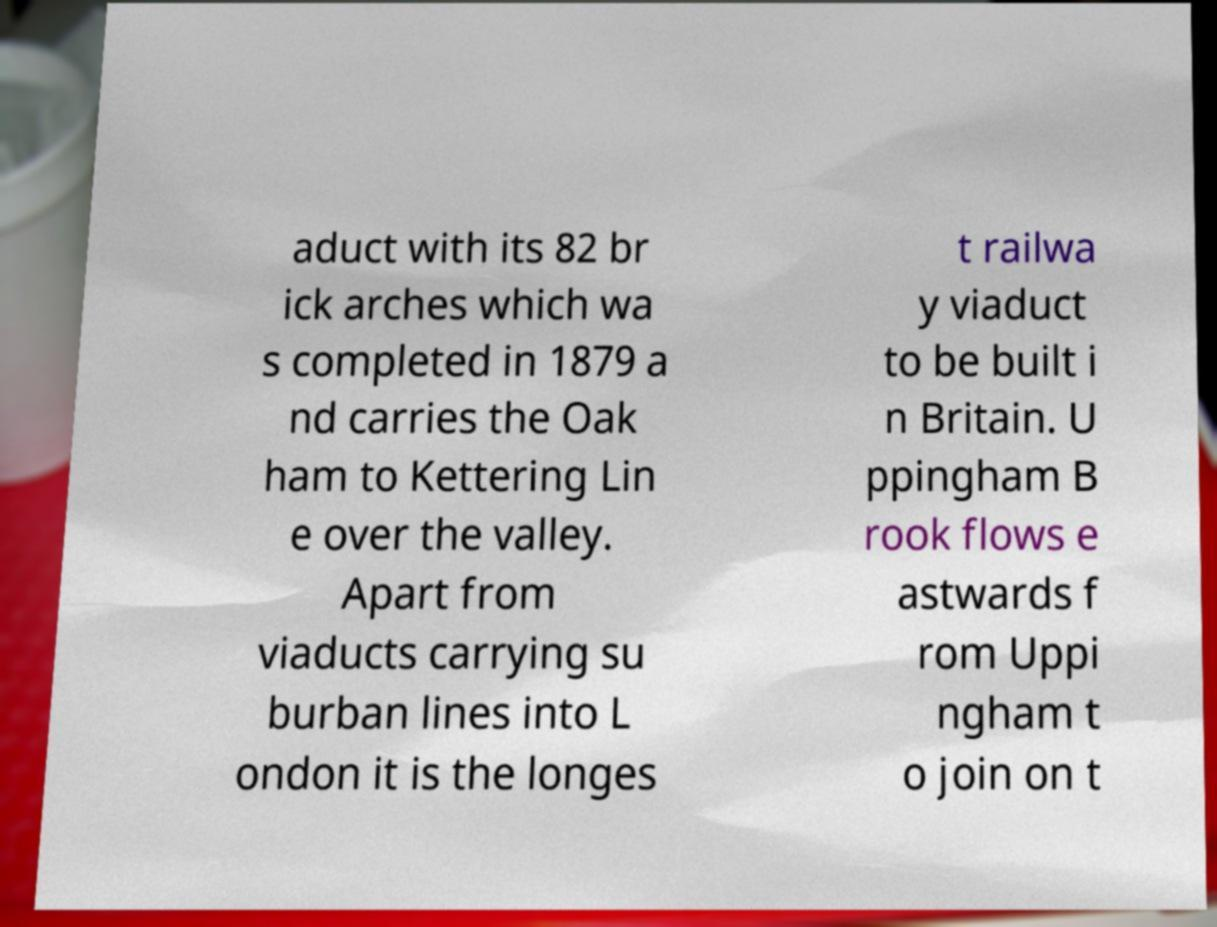Can you read and provide the text displayed in the image?This photo seems to have some interesting text. Can you extract and type it out for me? aduct with its 82 br ick arches which wa s completed in 1879 a nd carries the Oak ham to Kettering Lin e over the valley. Apart from viaducts carrying su burban lines into L ondon it is the longes t railwa y viaduct to be built i n Britain. U ppingham B rook flows e astwards f rom Uppi ngham t o join on t 